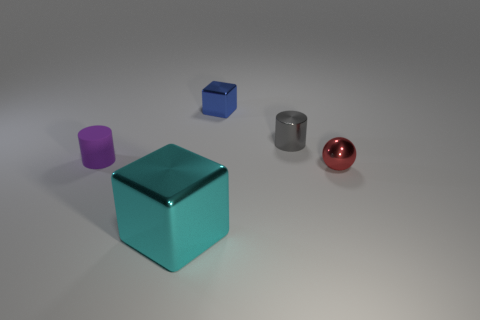Subtract all spheres. How many objects are left? 4 Add 1 tiny yellow rubber cubes. How many objects exist? 6 Subtract 2 cylinders. How many cylinders are left? 0 Add 1 small balls. How many small balls are left? 2 Add 3 cyan metal blocks. How many cyan metal blocks exist? 4 Subtract 0 yellow spheres. How many objects are left? 5 Subtract all gray cylinders. Subtract all green spheres. How many cylinders are left? 1 Subtract all blue cylinders. How many blue blocks are left? 1 Subtract all blue metallic cubes. Subtract all cylinders. How many objects are left? 2 